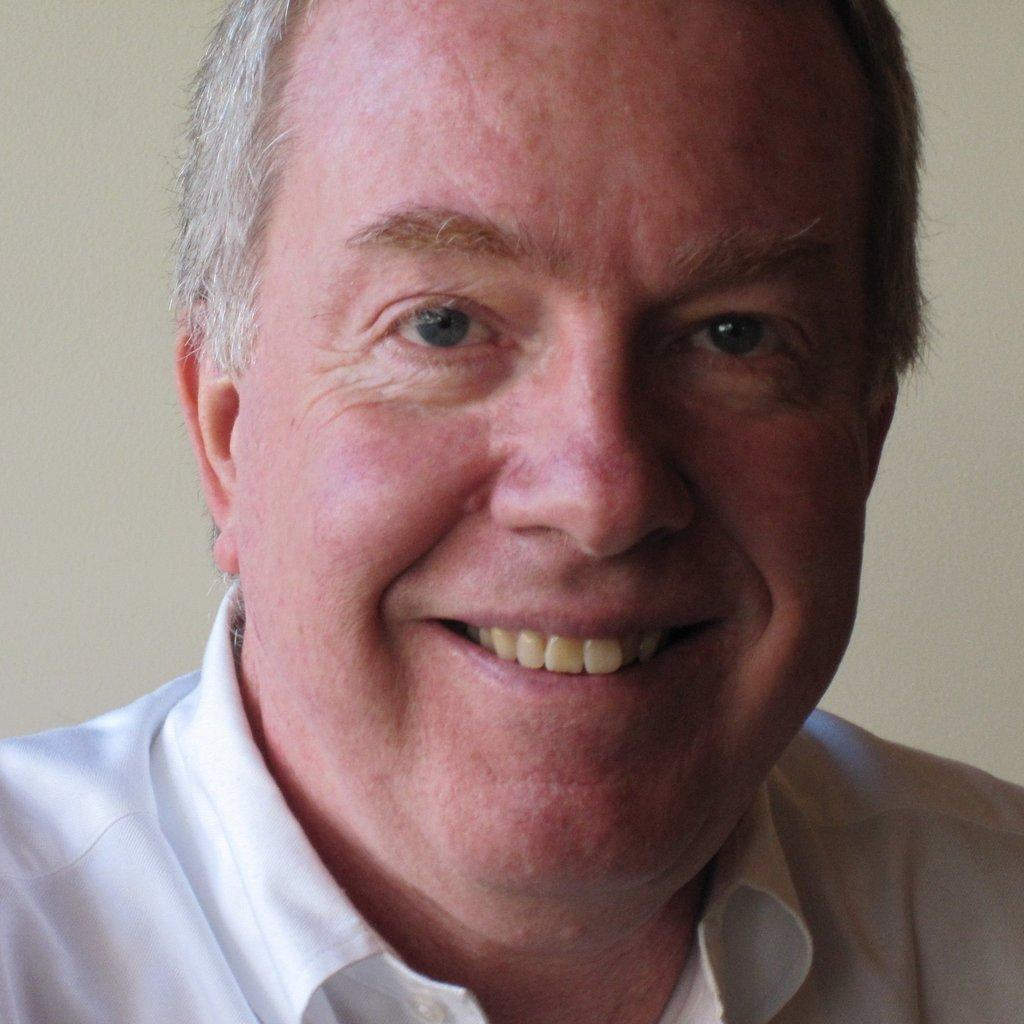What is the main subject of the image? There is a person in the image. Can you describe the person's appearance? The person has white hair and is wearing a white shirt. What is the color of the background in the image? The background of the image is white. What type of prison is visible in the background of the image? There is no prison present in the image; the background is white. Who is the manager of the person in the image? The facts provided do not mention a manager, so it cannot be determined from the image. 